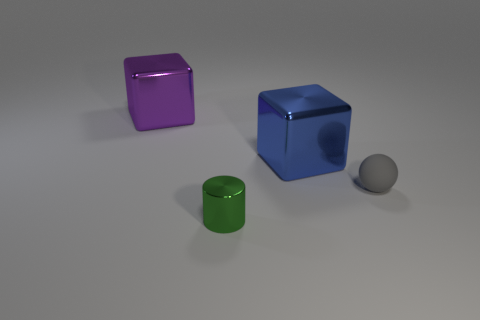Add 2 yellow matte cylinders. How many objects exist? 6 Subtract all spheres. How many objects are left? 3 Add 1 large purple blocks. How many large purple blocks are left? 2 Add 4 small cyan cubes. How many small cyan cubes exist? 4 Subtract 0 yellow cubes. How many objects are left? 4 Subtract all purple shiny things. Subtract all blue objects. How many objects are left? 2 